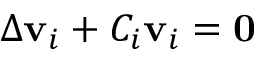<formula> <loc_0><loc_0><loc_500><loc_500>\Delta v _ { i } + C _ { i } v _ { i } = 0</formula> 